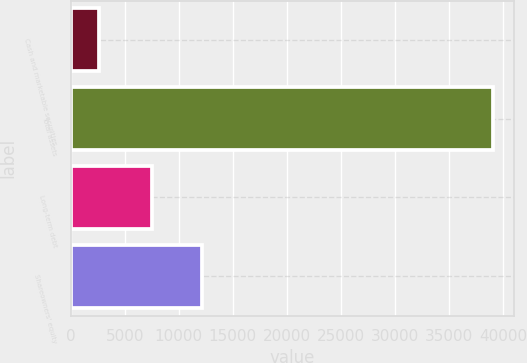Convert chart to OTSL. <chart><loc_0><loc_0><loc_500><loc_500><bar_chart><fcel>Cash and marketable securities<fcel>Total assets<fcel>Long-term debt<fcel>Shareowners' equity<nl><fcel>2604<fcel>39042<fcel>7506<fcel>12183<nl></chart> 